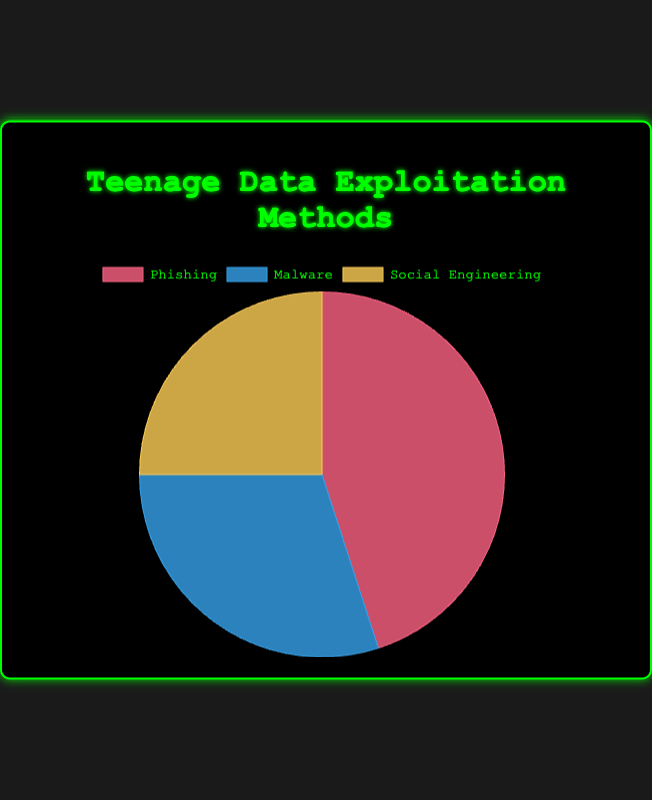what percentage of the methods used involve psychological tactics like manipulation? The figure shows three methods: Phishing, Malware, and Social Engineering, with percentages 45%, 30%, and 25% respectively. Social Engineering involves psychological tactics like manipulation.
Answer: 25% which method is used the most to handle personal data consumed by teenagers? By observing the percentages in the figure, Phishing has the highest percentage at 45% compared to Malware at 30% and Social Engineering at 25%.
Answer: Phishing what is the difference in percentage between the most and least used methods? The most used method is Phishing at 45% and the least used is Social Engineering at 25%. The difference is calculated as 45% - 25%.
Answer: 20% how much greater is the use of Phishing compared to Malware? The figure shows Phishing is 45% and Malware is 30%. The difference is calculated as 45% - 30%.
Answer: 15% what is the total percentage of the methods that do not involve malware? The methods not involving malware are Phishing (45%) and Social Engineering (25%). The total percentage is 45% + 25%.
Answer: 70% which segment of the pie chart is colored red? By observing the colors assigned to each segment in the pie chart, the segment colored red represents Phishing.
Answer: Phishing if you combine the percentages of Malware and Social Engineering, is it greater than Phishing? The combined percentage of Malware (30%) and Social Engineering (25%) is calculated as 30% + 25%, which is greater than the percentage for Phishing (45%).
Answer: Yes how does the percentage of Malware compare to the sum of percentages for Phishing and Social Engineering? The percentage for Malware is 30%. The sum of percentages for Phishing (45%) and Social Engineering (25%) is 45% + 25%, which equals 70%. Hence, Malware is less than this sum.
Answer: less in terms of visual size, which segment appears larger among the three methods? The segment representing Phishing appears larger compared to Malware and Social Engineering based on the percentages shown in the figure.
Answer: Phishing 